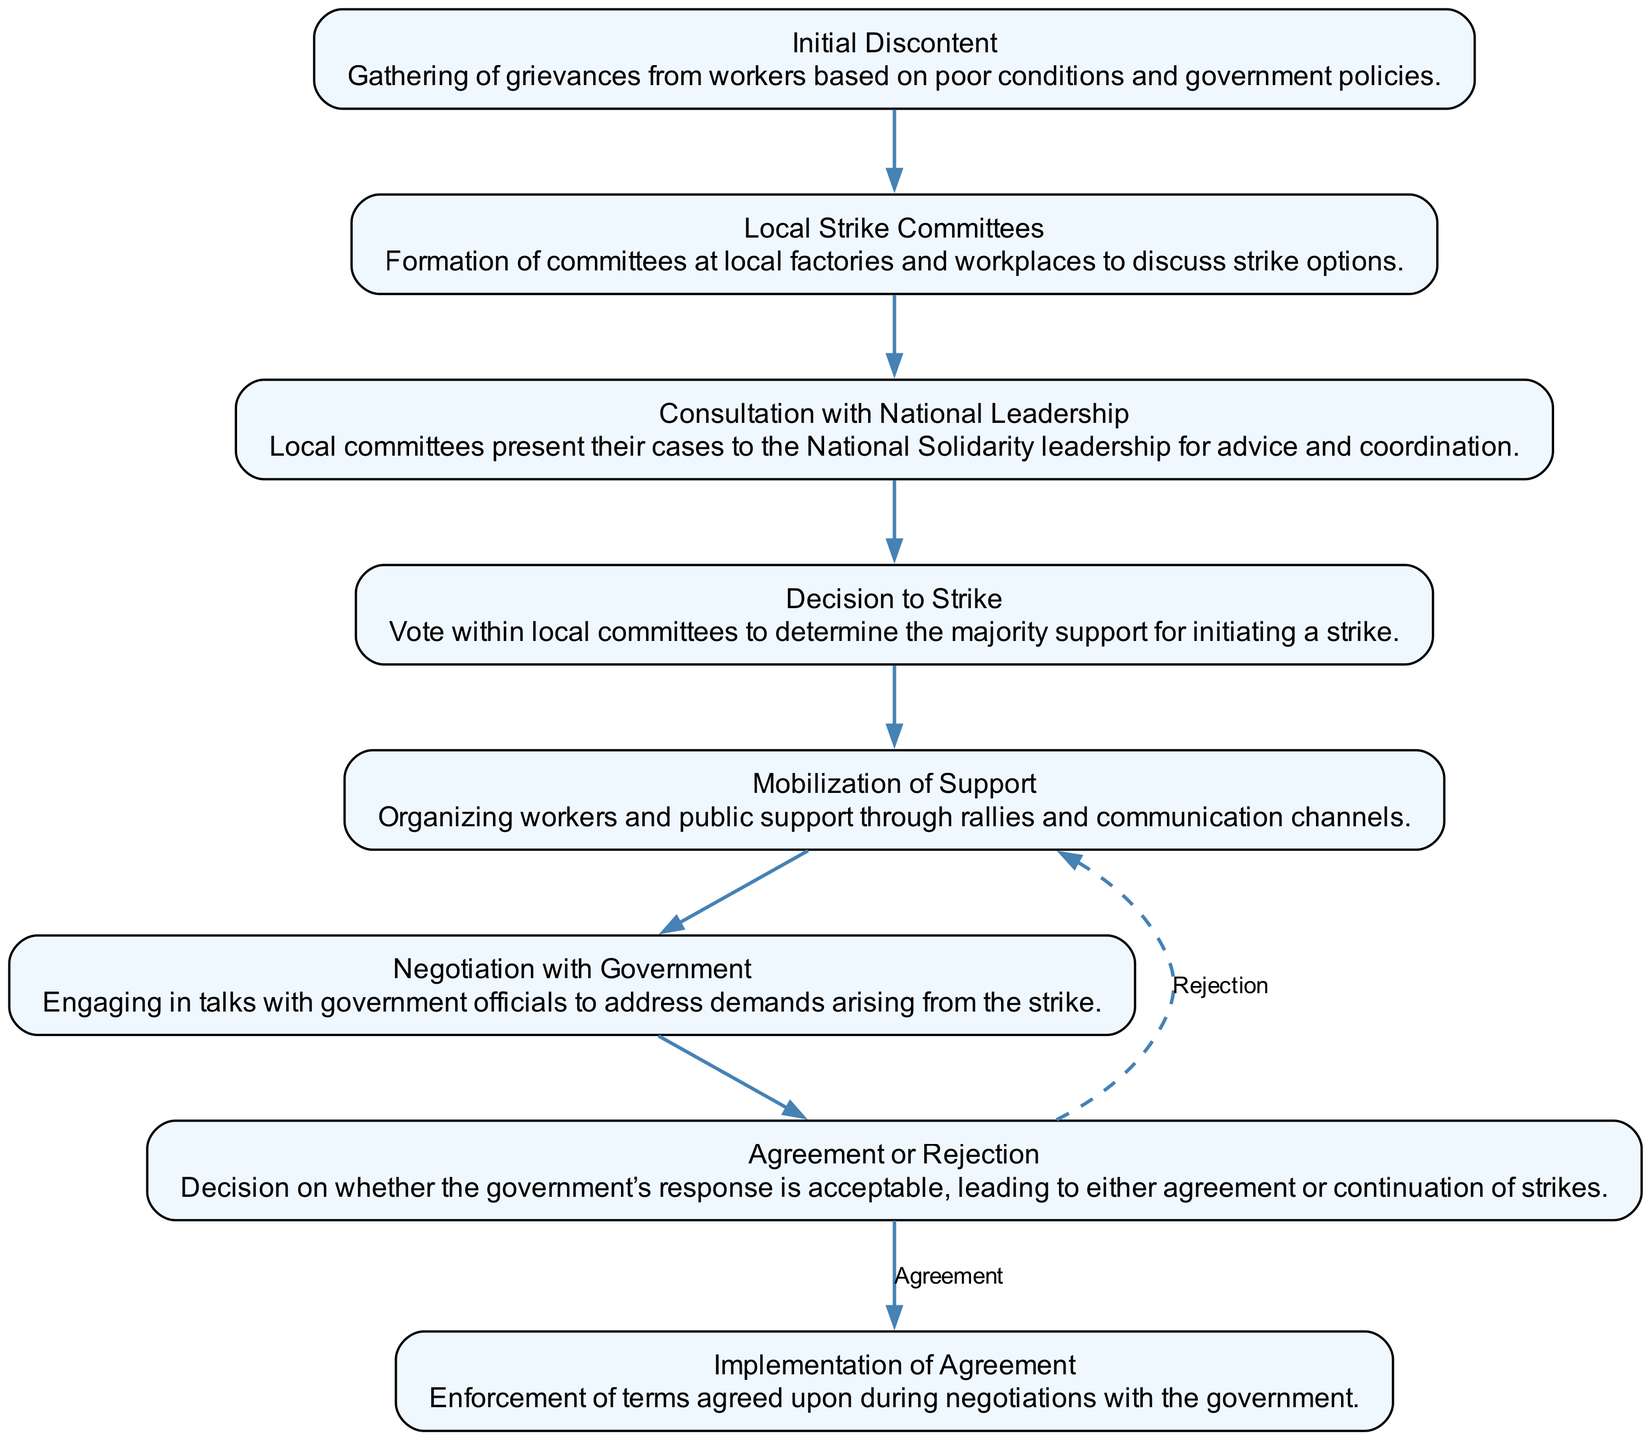What is the first step in the decision-making process? The diagram indicates that the first step is 'Initial Discontent,' which involves gathering grievances from workers.
Answer: Initial Discontent How many nodes are present in the diagram? By counting each unique step in the decision-making process depicted in the diagram, we find there are eight nodes.
Answer: Eight What step follows the 'Local Strike Committees'? The arrow in the diagram leads from 'Local Strike Committees' to 'Consultation with National Leadership,' indicating this is the next step.
Answer: Consultation with National Leadership Which step has an option to return to a prior step? The 'Agreement or Rejection' step has two subsequent paths—one leading to 'Implementation of Agreement' and the other returning to 'Mobilization of Support' if the response is rejected.
Answer: Mobilization of Support What is the last step in the process? The final step according to the flow of the diagram is 'Implementation of Agreement,' where the terms of any agreement achieved are enforced.
Answer: Implementation of Agreement How many edges are there in total in the diagram? By reviewing the connections between the nodes, the diagram has a total of seven edges that represent the flow from one step to the next.
Answer: Seven What happens if the government's response is rejected? According to the 'Agreement or Rejection' step, if the government’s response is unacceptable, the process continues with 'Mobilization of Support.'
Answer: Mobilization of Support Which node represents the action of organizing rallies? The diagram illustrates that 'Mobilization of Support' encompasses the action of organizing workers and public support, including rallies.
Answer: Mobilization of Support 